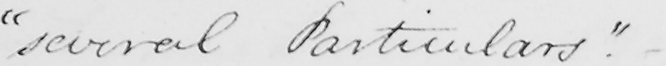What text is written in this handwritten line? " several Particulars "  . - 